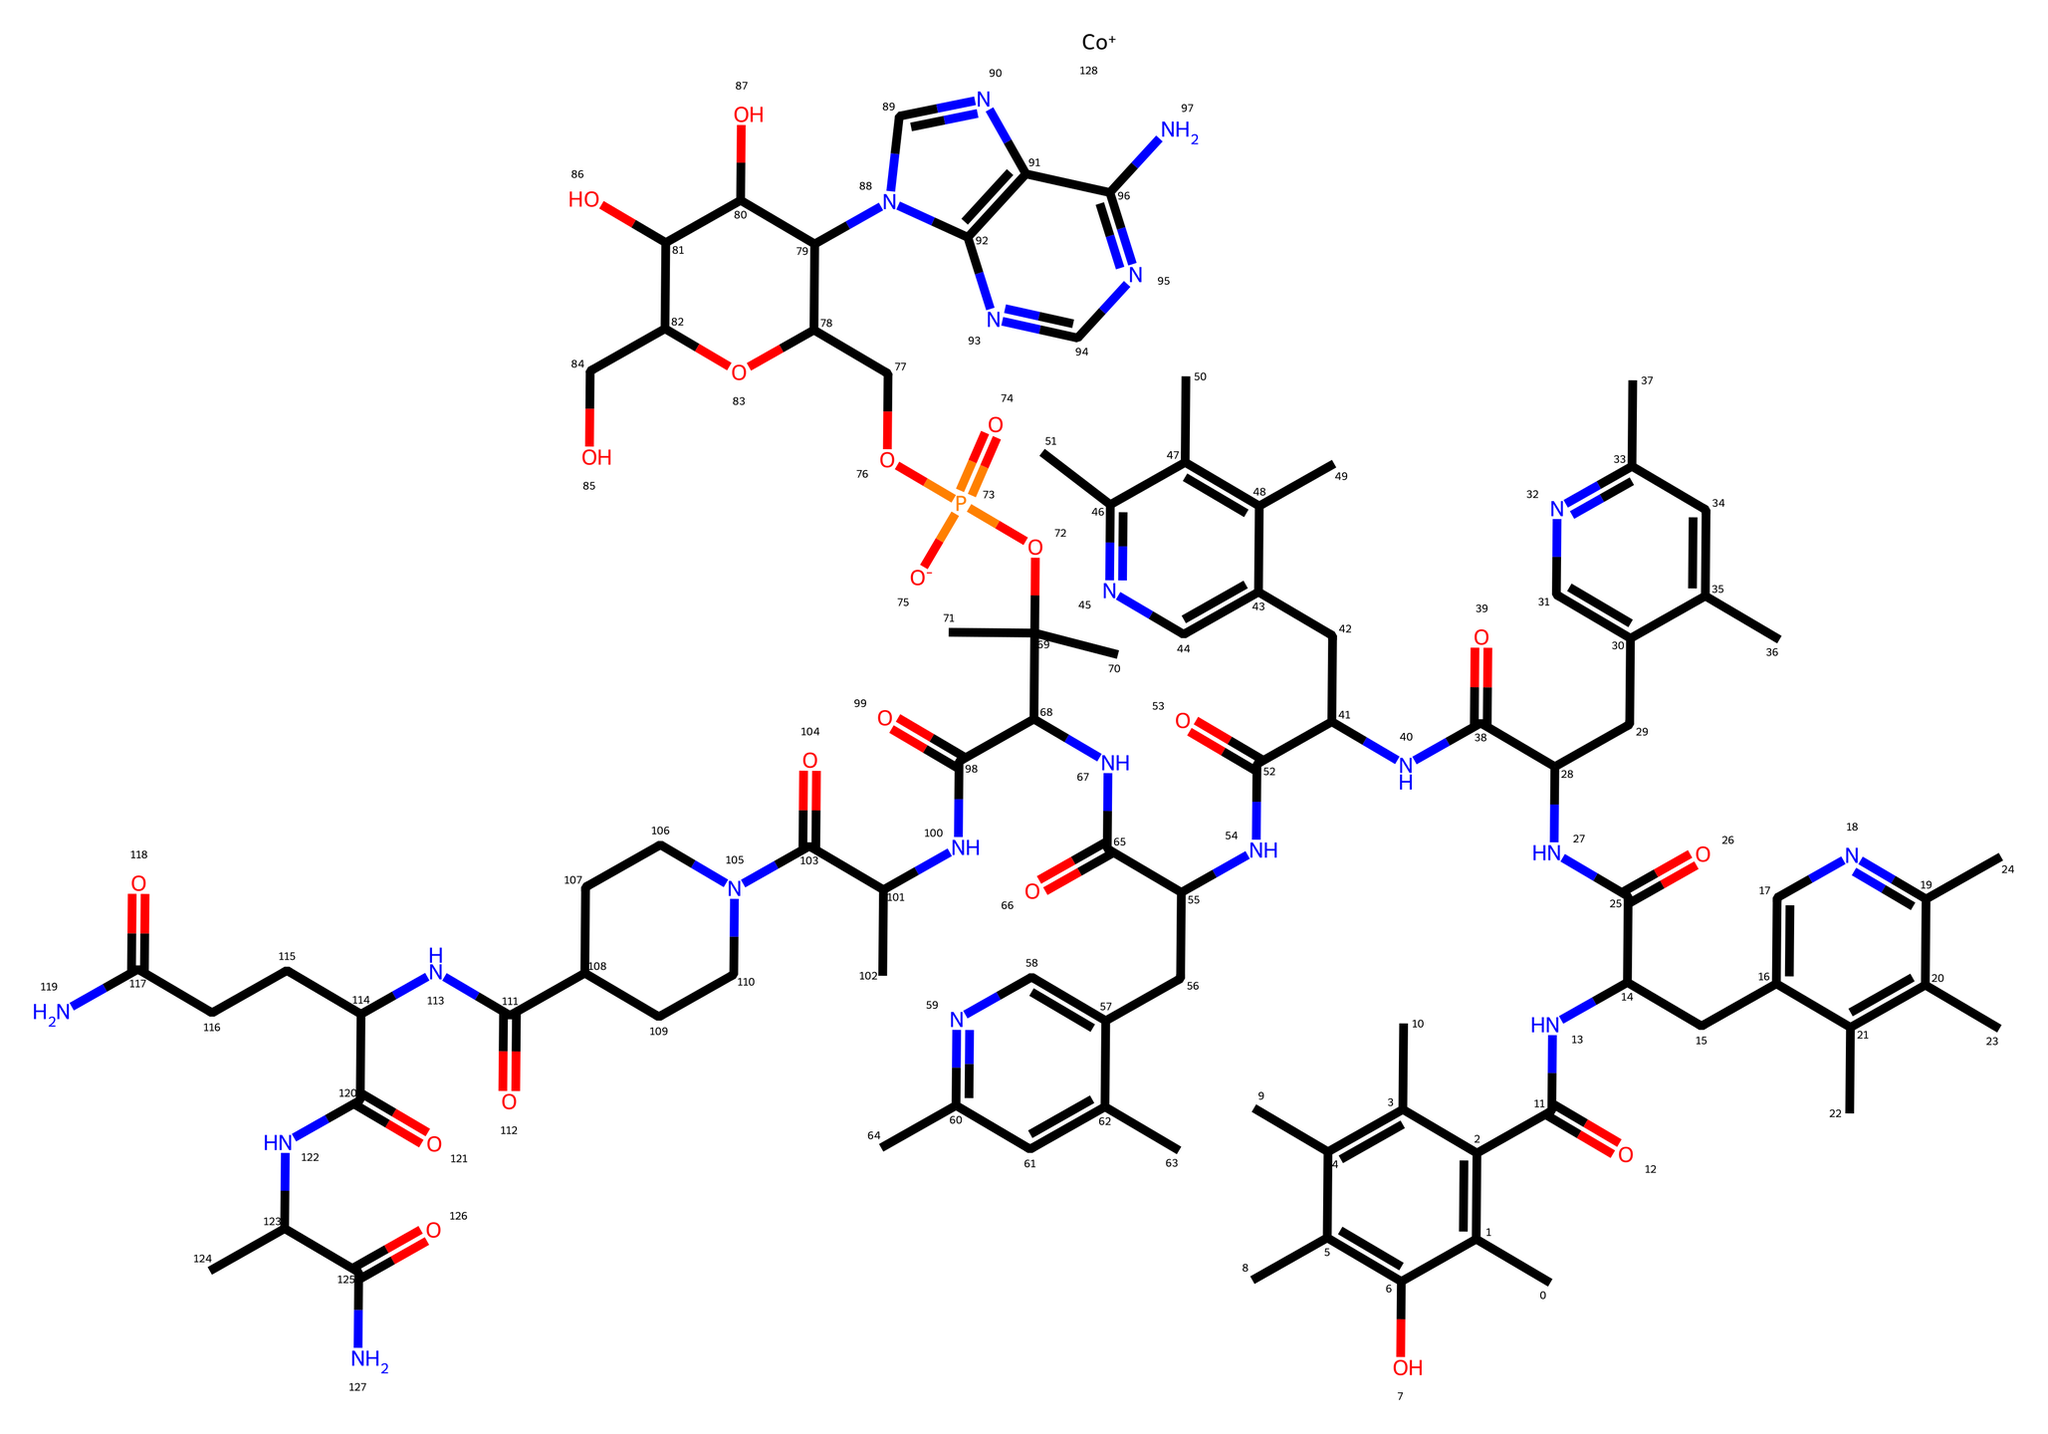What is the molecular formula of vitamin B12? To find the molecular formula, count the number of each type of atom in the SMILES representation. In this case, the formula is C63H88CoN14O14P.
Answer: C63H88CoN14O14P How many carbon atoms are present in the structure? Count the number of carbon (C) atoms indicated in the SMILES. There are 63 carbon atoms in this structure.
Answer: 63 What role does vitamin B12 play in cognitive function? Vitamin B12 is crucial for neuroprotection and myelin sheath formation, impacting cognitive processes.
Answer: Neuroprotection Is there a presence of cobalt in the structure? Cobalt (Co) is indicated in the SMILES, confirming that it is an essential element of vitamin B12.
Answer: Yes How many nitrogen atoms are present in the chemical structure? Count the number of nitrogen (N) atoms indicated in the SMILES; there are 14 nitrogen atoms in the structure.
Answer: 14 Which part of the chemical structure is responsible for its vitamin classification? The presence of the corrole ring and the cobalt ion is characteristic of vitamin B12, distinguishing it as a vitamin.
Answer: Cobalt ion What type of chemical compound is vitamin B12 classified as? Vitamin B12 is classified as a cobalamin, a type of vitamin characterized by its complex structure including cobalt.
Answer: Cobalamin 